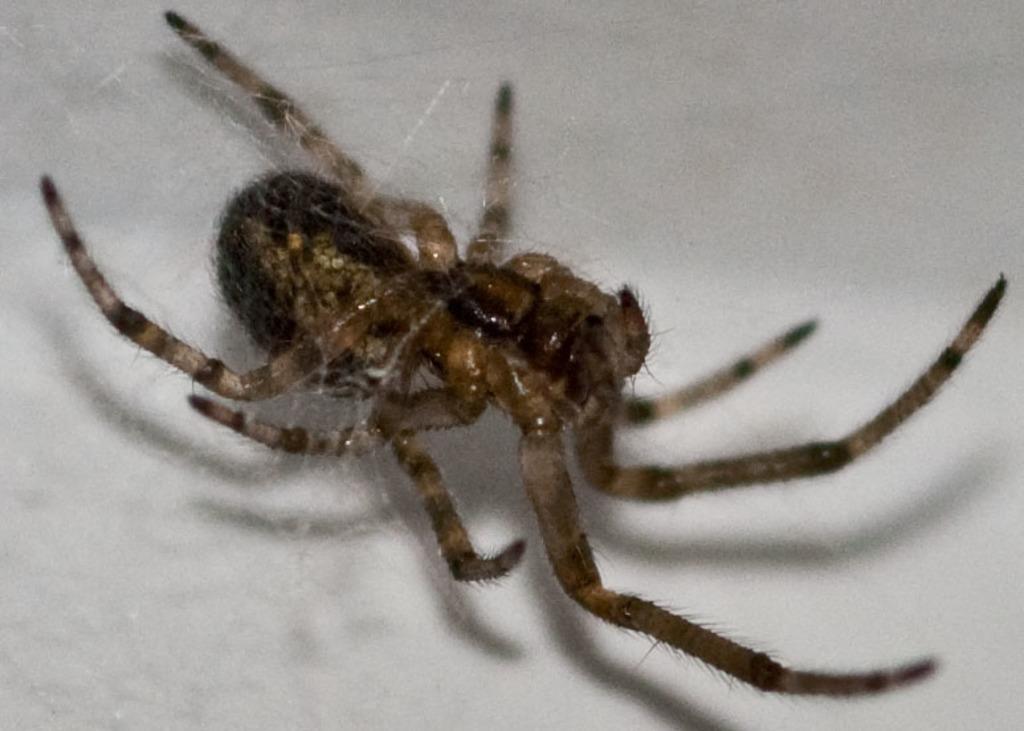Can you describe this image briefly? In this image I can see a spider which is brown and black in color is attached to its web. I can see the white colored background. 